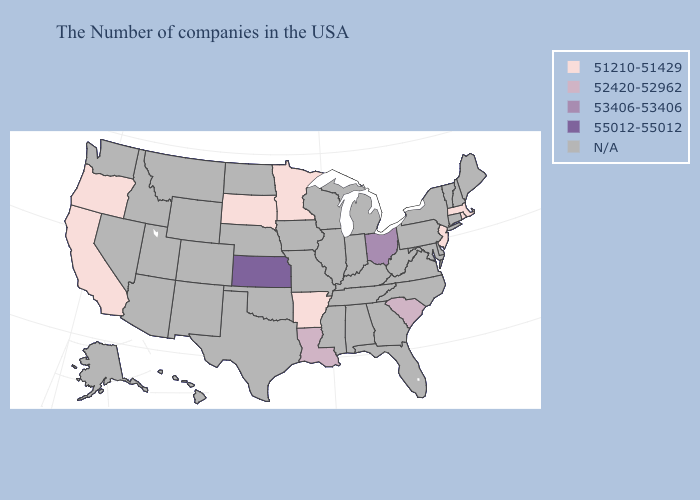Does the map have missing data?
Quick response, please. Yes. What is the value of Wyoming?
Give a very brief answer. N/A. Name the states that have a value in the range N/A?
Concise answer only. Maine, New Hampshire, Vermont, Connecticut, New York, Delaware, Maryland, Pennsylvania, Virginia, North Carolina, West Virginia, Florida, Georgia, Michigan, Kentucky, Indiana, Alabama, Tennessee, Wisconsin, Illinois, Mississippi, Missouri, Iowa, Nebraska, Oklahoma, Texas, North Dakota, Wyoming, Colorado, New Mexico, Utah, Montana, Arizona, Idaho, Nevada, Washington, Alaska, Hawaii. What is the value of Washington?
Answer briefly. N/A. Does Minnesota have the lowest value in the USA?
Concise answer only. Yes. Name the states that have a value in the range N/A?
Write a very short answer. Maine, New Hampshire, Vermont, Connecticut, New York, Delaware, Maryland, Pennsylvania, Virginia, North Carolina, West Virginia, Florida, Georgia, Michigan, Kentucky, Indiana, Alabama, Tennessee, Wisconsin, Illinois, Mississippi, Missouri, Iowa, Nebraska, Oklahoma, Texas, North Dakota, Wyoming, Colorado, New Mexico, Utah, Montana, Arizona, Idaho, Nevada, Washington, Alaska, Hawaii. What is the lowest value in states that border Nevada?
Be succinct. 51210-51429. Name the states that have a value in the range N/A?
Write a very short answer. Maine, New Hampshire, Vermont, Connecticut, New York, Delaware, Maryland, Pennsylvania, Virginia, North Carolina, West Virginia, Florida, Georgia, Michigan, Kentucky, Indiana, Alabama, Tennessee, Wisconsin, Illinois, Mississippi, Missouri, Iowa, Nebraska, Oklahoma, Texas, North Dakota, Wyoming, Colorado, New Mexico, Utah, Montana, Arizona, Idaho, Nevada, Washington, Alaska, Hawaii. What is the value of Wyoming?
Answer briefly. N/A. Name the states that have a value in the range 55012-55012?
Quick response, please. Kansas. Which states have the lowest value in the USA?
Be succinct. Massachusetts, Rhode Island, New Jersey, Arkansas, Minnesota, South Dakota, California, Oregon. Name the states that have a value in the range 55012-55012?
Keep it brief. Kansas. What is the lowest value in the West?
Short answer required. 51210-51429. 